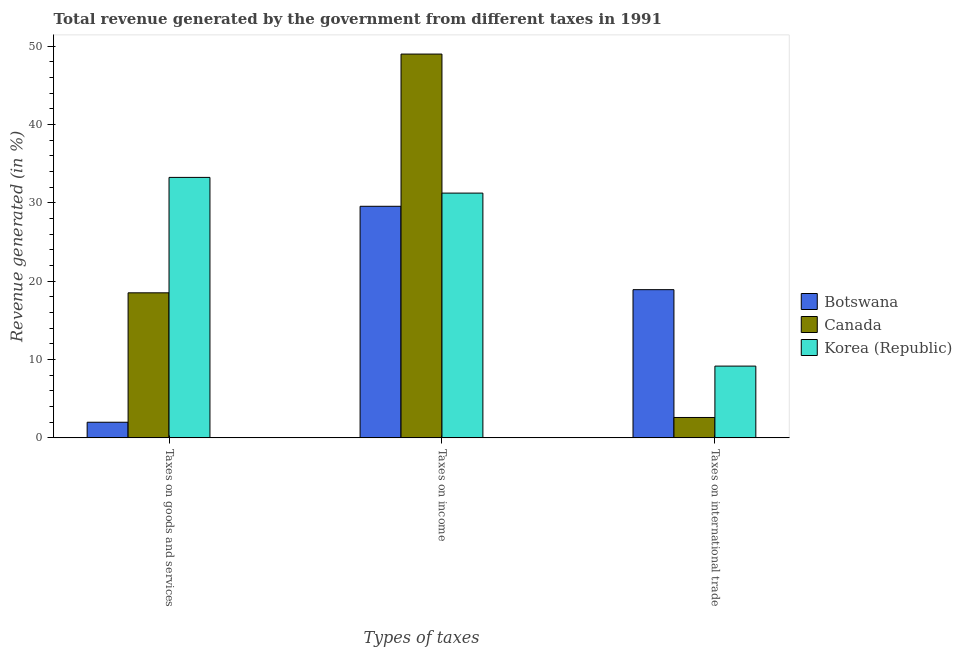Are the number of bars on each tick of the X-axis equal?
Make the answer very short. Yes. How many bars are there on the 1st tick from the left?
Offer a terse response. 3. What is the label of the 1st group of bars from the left?
Your response must be concise. Taxes on goods and services. What is the percentage of revenue generated by taxes on goods and services in Canada?
Keep it short and to the point. 18.52. Across all countries, what is the maximum percentage of revenue generated by tax on international trade?
Keep it short and to the point. 18.92. Across all countries, what is the minimum percentage of revenue generated by tax on international trade?
Your answer should be compact. 2.6. In which country was the percentage of revenue generated by tax on international trade maximum?
Provide a succinct answer. Botswana. In which country was the percentage of revenue generated by tax on international trade minimum?
Your answer should be compact. Canada. What is the total percentage of revenue generated by taxes on income in the graph?
Offer a very short reply. 109.83. What is the difference between the percentage of revenue generated by taxes on goods and services in Botswana and that in Canada?
Your response must be concise. -16.53. What is the difference between the percentage of revenue generated by taxes on goods and services in Canada and the percentage of revenue generated by taxes on income in Botswana?
Your answer should be very brief. -11.05. What is the average percentage of revenue generated by taxes on income per country?
Your answer should be compact. 36.61. What is the difference between the percentage of revenue generated by tax on international trade and percentage of revenue generated by taxes on income in Canada?
Keep it short and to the point. -46.4. What is the ratio of the percentage of revenue generated by taxes on goods and services in Canada to that in Botswana?
Make the answer very short. 9.28. Is the difference between the percentage of revenue generated by tax on international trade in Korea (Republic) and Botswana greater than the difference between the percentage of revenue generated by taxes on income in Korea (Republic) and Botswana?
Provide a short and direct response. No. What is the difference between the highest and the second highest percentage of revenue generated by tax on international trade?
Your answer should be compact. 9.76. What is the difference between the highest and the lowest percentage of revenue generated by taxes on goods and services?
Offer a very short reply. 31.26. In how many countries, is the percentage of revenue generated by taxes on income greater than the average percentage of revenue generated by taxes on income taken over all countries?
Make the answer very short. 1. Is the sum of the percentage of revenue generated by tax on international trade in Canada and Botswana greater than the maximum percentage of revenue generated by taxes on income across all countries?
Offer a very short reply. No. How many bars are there?
Give a very brief answer. 9. Are all the bars in the graph horizontal?
Provide a succinct answer. No. How many countries are there in the graph?
Offer a terse response. 3. What is the difference between two consecutive major ticks on the Y-axis?
Keep it short and to the point. 10. Are the values on the major ticks of Y-axis written in scientific E-notation?
Your response must be concise. No. Does the graph contain any zero values?
Provide a short and direct response. No. Where does the legend appear in the graph?
Provide a succinct answer. Center right. How many legend labels are there?
Keep it short and to the point. 3. How are the legend labels stacked?
Your answer should be very brief. Vertical. What is the title of the graph?
Your response must be concise. Total revenue generated by the government from different taxes in 1991. What is the label or title of the X-axis?
Your answer should be very brief. Types of taxes. What is the label or title of the Y-axis?
Make the answer very short. Revenue generated (in %). What is the Revenue generated (in %) in Botswana in Taxes on goods and services?
Your answer should be very brief. 2. What is the Revenue generated (in %) of Canada in Taxes on goods and services?
Make the answer very short. 18.52. What is the Revenue generated (in %) in Korea (Republic) in Taxes on goods and services?
Offer a terse response. 33.26. What is the Revenue generated (in %) in Botswana in Taxes on income?
Offer a very short reply. 29.57. What is the Revenue generated (in %) in Canada in Taxes on income?
Keep it short and to the point. 49.01. What is the Revenue generated (in %) in Korea (Republic) in Taxes on income?
Your answer should be compact. 31.25. What is the Revenue generated (in %) in Botswana in Taxes on international trade?
Your answer should be very brief. 18.92. What is the Revenue generated (in %) of Canada in Taxes on international trade?
Your answer should be compact. 2.6. What is the Revenue generated (in %) of Korea (Republic) in Taxes on international trade?
Give a very brief answer. 9.16. Across all Types of taxes, what is the maximum Revenue generated (in %) of Botswana?
Your answer should be very brief. 29.57. Across all Types of taxes, what is the maximum Revenue generated (in %) in Canada?
Make the answer very short. 49.01. Across all Types of taxes, what is the maximum Revenue generated (in %) in Korea (Republic)?
Make the answer very short. 33.26. Across all Types of taxes, what is the minimum Revenue generated (in %) of Botswana?
Make the answer very short. 2. Across all Types of taxes, what is the minimum Revenue generated (in %) of Canada?
Make the answer very short. 2.6. Across all Types of taxes, what is the minimum Revenue generated (in %) in Korea (Republic)?
Offer a very short reply. 9.16. What is the total Revenue generated (in %) of Botswana in the graph?
Make the answer very short. 50.49. What is the total Revenue generated (in %) in Canada in the graph?
Keep it short and to the point. 70.13. What is the total Revenue generated (in %) in Korea (Republic) in the graph?
Provide a succinct answer. 73.68. What is the difference between the Revenue generated (in %) in Botswana in Taxes on goods and services and that in Taxes on income?
Give a very brief answer. -27.57. What is the difference between the Revenue generated (in %) of Canada in Taxes on goods and services and that in Taxes on income?
Provide a succinct answer. -30.49. What is the difference between the Revenue generated (in %) in Korea (Republic) in Taxes on goods and services and that in Taxes on income?
Provide a short and direct response. 2.01. What is the difference between the Revenue generated (in %) in Botswana in Taxes on goods and services and that in Taxes on international trade?
Your response must be concise. -16.93. What is the difference between the Revenue generated (in %) of Canada in Taxes on goods and services and that in Taxes on international trade?
Your answer should be very brief. 15.92. What is the difference between the Revenue generated (in %) in Korea (Republic) in Taxes on goods and services and that in Taxes on international trade?
Give a very brief answer. 24.1. What is the difference between the Revenue generated (in %) of Botswana in Taxes on income and that in Taxes on international trade?
Ensure brevity in your answer.  10.64. What is the difference between the Revenue generated (in %) in Canada in Taxes on income and that in Taxes on international trade?
Give a very brief answer. 46.4. What is the difference between the Revenue generated (in %) in Korea (Republic) in Taxes on income and that in Taxes on international trade?
Offer a terse response. 22.09. What is the difference between the Revenue generated (in %) of Botswana in Taxes on goods and services and the Revenue generated (in %) of Canada in Taxes on income?
Keep it short and to the point. -47.01. What is the difference between the Revenue generated (in %) in Botswana in Taxes on goods and services and the Revenue generated (in %) in Korea (Republic) in Taxes on income?
Provide a short and direct response. -29.26. What is the difference between the Revenue generated (in %) in Canada in Taxes on goods and services and the Revenue generated (in %) in Korea (Republic) in Taxes on income?
Offer a very short reply. -12.73. What is the difference between the Revenue generated (in %) in Botswana in Taxes on goods and services and the Revenue generated (in %) in Canada in Taxes on international trade?
Your response must be concise. -0.61. What is the difference between the Revenue generated (in %) in Botswana in Taxes on goods and services and the Revenue generated (in %) in Korea (Republic) in Taxes on international trade?
Your response must be concise. -7.17. What is the difference between the Revenue generated (in %) in Canada in Taxes on goods and services and the Revenue generated (in %) in Korea (Republic) in Taxes on international trade?
Offer a very short reply. 9.36. What is the difference between the Revenue generated (in %) in Botswana in Taxes on income and the Revenue generated (in %) in Canada in Taxes on international trade?
Ensure brevity in your answer.  26.97. What is the difference between the Revenue generated (in %) of Botswana in Taxes on income and the Revenue generated (in %) of Korea (Republic) in Taxes on international trade?
Provide a short and direct response. 20.41. What is the difference between the Revenue generated (in %) of Canada in Taxes on income and the Revenue generated (in %) of Korea (Republic) in Taxes on international trade?
Your answer should be compact. 39.84. What is the average Revenue generated (in %) in Botswana per Types of taxes?
Make the answer very short. 16.83. What is the average Revenue generated (in %) of Canada per Types of taxes?
Your answer should be very brief. 23.38. What is the average Revenue generated (in %) in Korea (Republic) per Types of taxes?
Provide a short and direct response. 24.56. What is the difference between the Revenue generated (in %) in Botswana and Revenue generated (in %) in Canada in Taxes on goods and services?
Offer a very short reply. -16.53. What is the difference between the Revenue generated (in %) of Botswana and Revenue generated (in %) of Korea (Republic) in Taxes on goods and services?
Offer a very short reply. -31.26. What is the difference between the Revenue generated (in %) in Canada and Revenue generated (in %) in Korea (Republic) in Taxes on goods and services?
Your response must be concise. -14.74. What is the difference between the Revenue generated (in %) in Botswana and Revenue generated (in %) in Canada in Taxes on income?
Provide a succinct answer. -19.44. What is the difference between the Revenue generated (in %) of Botswana and Revenue generated (in %) of Korea (Republic) in Taxes on income?
Provide a short and direct response. -1.68. What is the difference between the Revenue generated (in %) of Canada and Revenue generated (in %) of Korea (Republic) in Taxes on income?
Provide a short and direct response. 17.75. What is the difference between the Revenue generated (in %) in Botswana and Revenue generated (in %) in Canada in Taxes on international trade?
Make the answer very short. 16.32. What is the difference between the Revenue generated (in %) of Botswana and Revenue generated (in %) of Korea (Republic) in Taxes on international trade?
Your answer should be compact. 9.76. What is the difference between the Revenue generated (in %) in Canada and Revenue generated (in %) in Korea (Republic) in Taxes on international trade?
Give a very brief answer. -6.56. What is the ratio of the Revenue generated (in %) of Botswana in Taxes on goods and services to that in Taxes on income?
Your response must be concise. 0.07. What is the ratio of the Revenue generated (in %) of Canada in Taxes on goods and services to that in Taxes on income?
Offer a terse response. 0.38. What is the ratio of the Revenue generated (in %) of Korea (Republic) in Taxes on goods and services to that in Taxes on income?
Give a very brief answer. 1.06. What is the ratio of the Revenue generated (in %) of Botswana in Taxes on goods and services to that in Taxes on international trade?
Give a very brief answer. 0.11. What is the ratio of the Revenue generated (in %) of Canada in Taxes on goods and services to that in Taxes on international trade?
Provide a succinct answer. 7.12. What is the ratio of the Revenue generated (in %) of Korea (Republic) in Taxes on goods and services to that in Taxes on international trade?
Make the answer very short. 3.63. What is the ratio of the Revenue generated (in %) in Botswana in Taxes on income to that in Taxes on international trade?
Provide a succinct answer. 1.56. What is the ratio of the Revenue generated (in %) of Canada in Taxes on income to that in Taxes on international trade?
Offer a very short reply. 18.83. What is the ratio of the Revenue generated (in %) of Korea (Republic) in Taxes on income to that in Taxes on international trade?
Offer a very short reply. 3.41. What is the difference between the highest and the second highest Revenue generated (in %) of Botswana?
Your response must be concise. 10.64. What is the difference between the highest and the second highest Revenue generated (in %) of Canada?
Give a very brief answer. 30.49. What is the difference between the highest and the second highest Revenue generated (in %) in Korea (Republic)?
Make the answer very short. 2.01. What is the difference between the highest and the lowest Revenue generated (in %) in Botswana?
Ensure brevity in your answer.  27.57. What is the difference between the highest and the lowest Revenue generated (in %) in Canada?
Give a very brief answer. 46.4. What is the difference between the highest and the lowest Revenue generated (in %) in Korea (Republic)?
Ensure brevity in your answer.  24.1. 